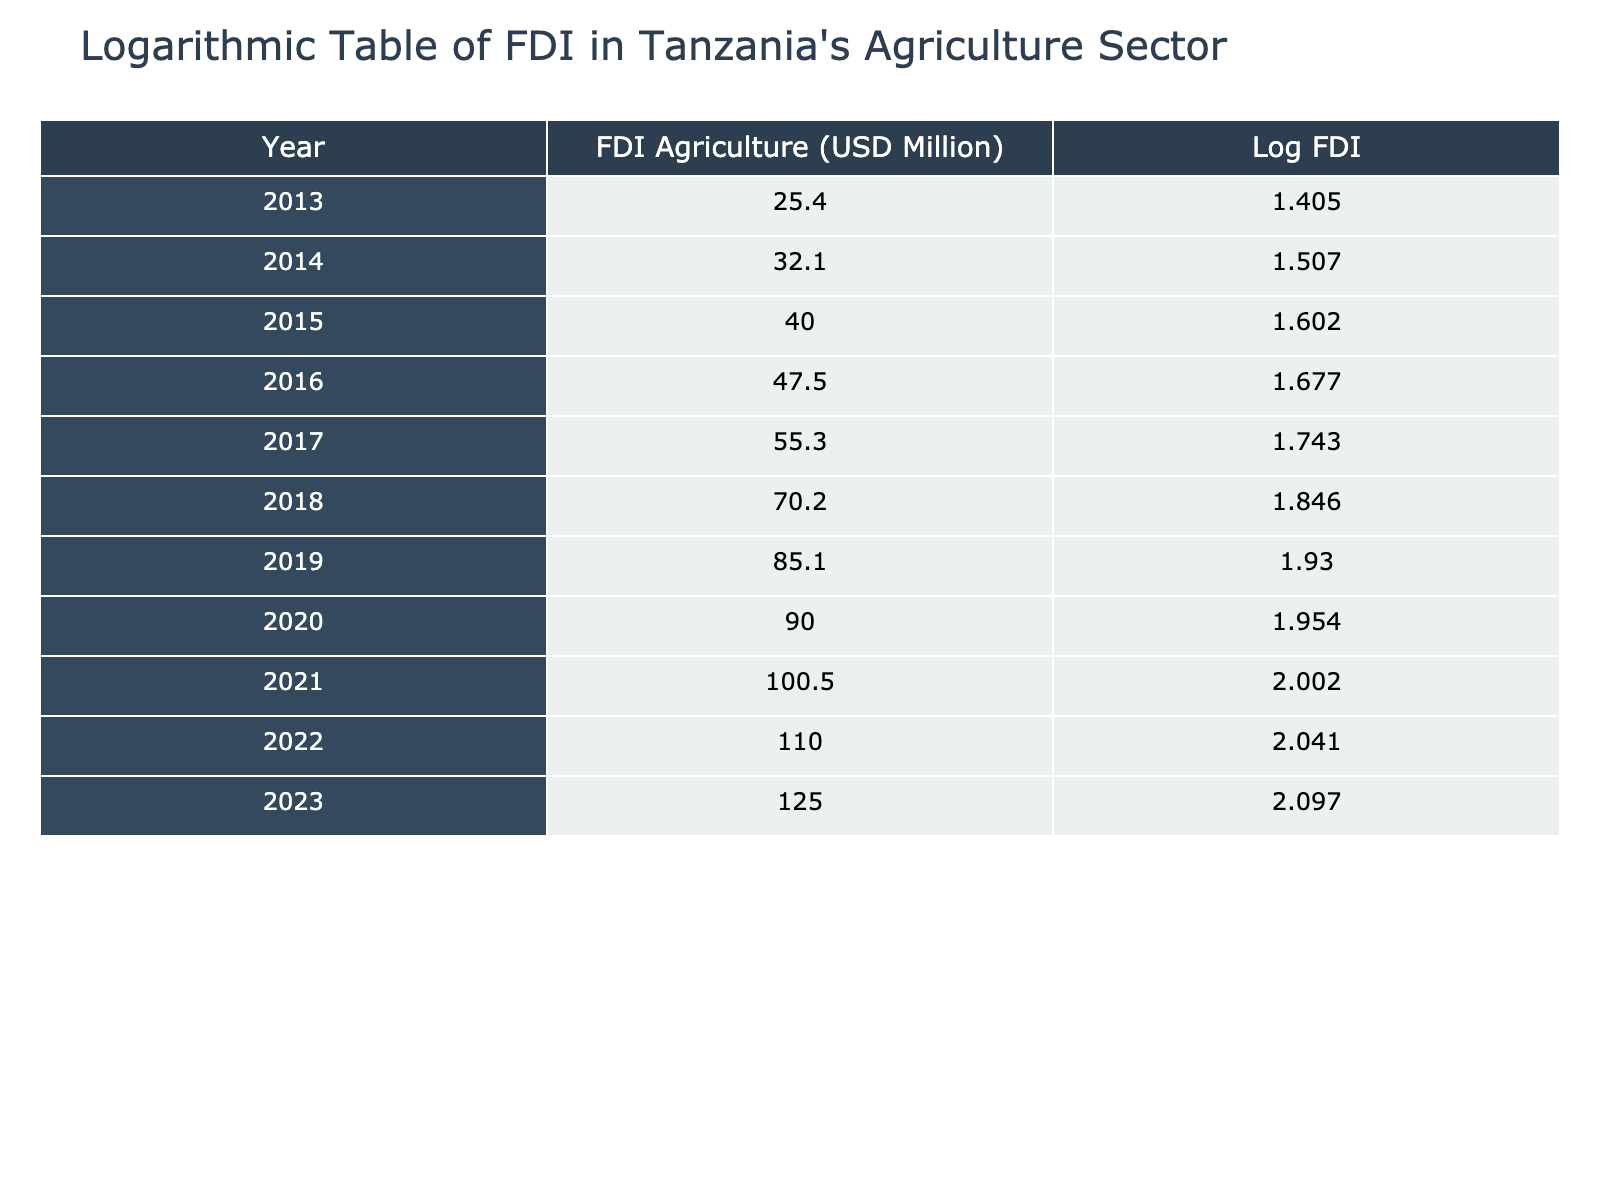What was the Foreign Direct Investment in Agriculture in Tanzania in 2013? The table shows that for the year 2013, the value listed under FDI Agriculture was 25.4 million USD.
Answer: 25.4 million USD In which year did the FDI Agriculture reach 100 million USD? According to the table, the FDI Agriculture crossed the 100 million USD mark in the year 2021.
Answer: 2021 What is the difference in FDI Agriculture between 2018 and 2023? From the table, in 2018 the FDI Agriculture was 70.2 million USD, and in 2023 it was 125.0 million USD. The difference is 125.0 - 70.2 = 54.8 million USD.
Answer: 54.8 million USD Is the FDI Agriculture in 2014 greater than that in 2015? According to the values in the table, the FDI Agriculture in 2014 was 32.1 million USD and in 2015 it was 40.0 million USD. Since 32.1 is less than 40.0, the answer is no.
Answer: No What was the average FDI Agriculture from 2013 to 2020? The FDI values from 2013 to 2020 are 25.4, 32.1, 40.0, 47.5, 55.3, 70.2, 85.1, and 90.0. To find the average, we sum these values: 25.4 + 32.1 + 40.0 + 47.5 + 55.3 + 70.2 + 85.1 + 90.0 = 410.6. Then divide by 8 (the number of years), which gives us an average of 410.6 / 8 = 51.325 million USD.
Answer: 51.325 million USD Which year had the lowest FDI Agriculture and what was its value? The lowest value in the table is for the year 2013 at 25.4 million USD.
Answer: 2013, 25.4 million USD How much did the FDI Agriculture increase from 2016 to 2022? The FDI Agriculture in 2016 was 47.5 million USD and in 2022 it was 110.0 million USD. The increase is calculated as 110.0 - 47.5 = 62.5 million USD.
Answer: 62.5 million USD Was there an increase in FDI Agriculture from 2019 to 2020? The values are 85.1 million USD in 2019 and 90.0 million USD in 2020. Since 90.0 is greater than 85.1, the answer is yes.
Answer: Yes 